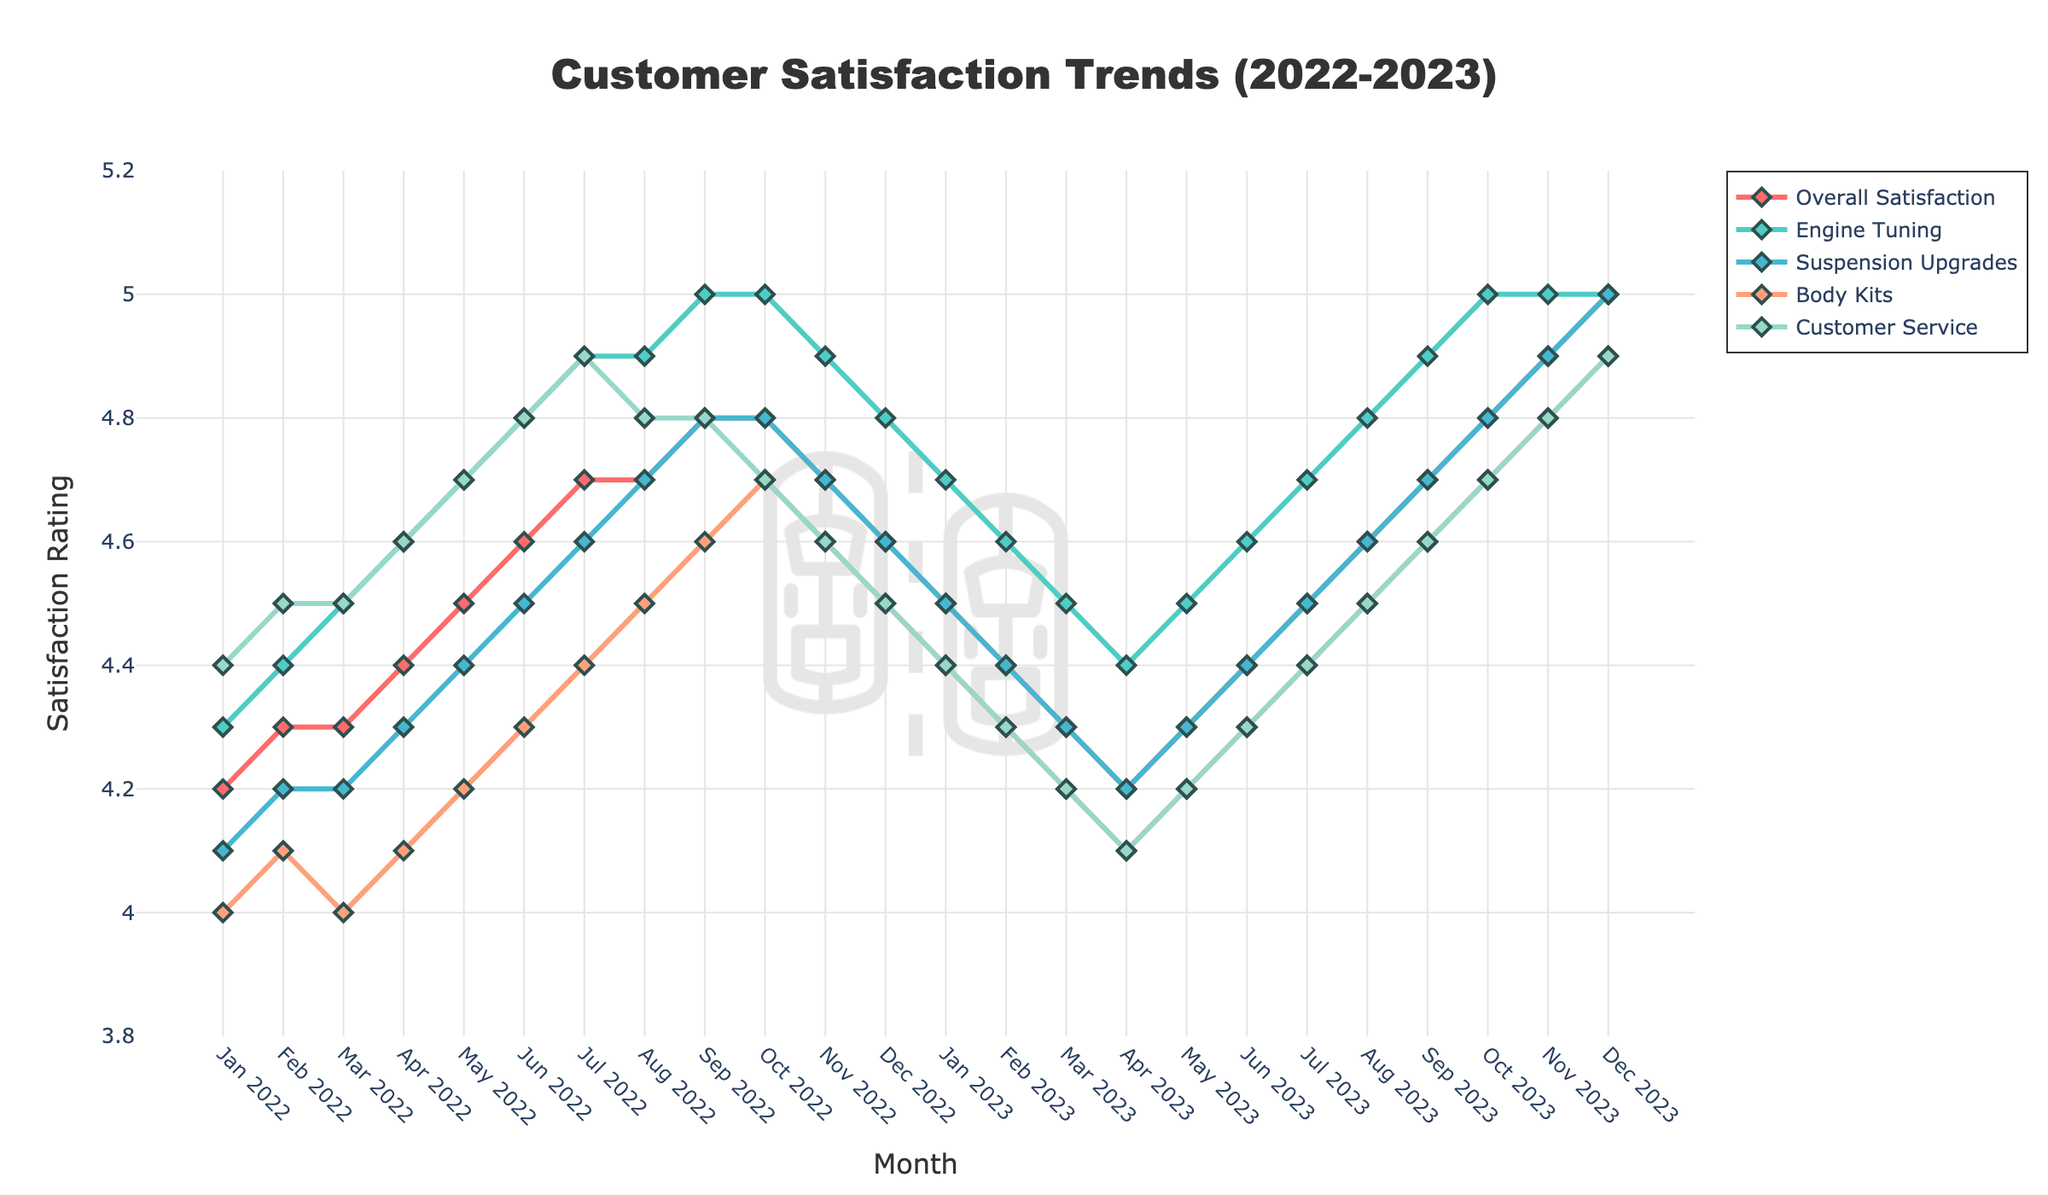Which service had the highest satisfaction rating in January 2022? In the figure, locate January 2022 on the x-axis and compare the satisfaction ratings of the services. The highest point indicates the highest satisfaction. Customer Service was the highest at 4.4.
Answer: Customer Service How did the overall satisfaction trend between January 2022 and December 2022? Look at the line for "Overall Satisfaction." It starts at 4.2 in January 2022 and rises consistently, peaking at 4.8 in September 2022, then slightly falls to 4.6 by December 2022.
Answer: It increased initially and then slightly declined Which service showed the most consistent satisfaction ratings over the 24 months? Compare the variability in the lines for each service. Engine Tuning maintains ratings between 4.4 and 5.0 without major fluctuations, indicating consistency.
Answer: Engine Tuning How much did the satisfaction rating for Body Kits change from its lowest to highest point? Identify the lowest and highest points on the Body Kits line. The lowest point is 4.0 (Jan 2022, Mar 2022), and the highest is 4.9 (Dec 2023). The change is 4.9 - 4.0.
Answer: 0.9 Which month had the highest overall satisfaction rating, and what was the rating? Check the peak points on the "Overall Satisfaction" line. It reaches its highest point in December 2023 with a rating of 5.0.
Answer: December 2023, 5.0 Between which months did Suspension Upgrades see the largest drop in satisfaction? Observe the drops in the "Suspension Upgrades" line. The most notable drop is between December 2022 (4.6) and March 2023 (4.3), a decline of 0.3 points.
Answer: December 2022 and March 2023 What is the average satisfaction rating for Customer Service over the entire period? Sum the Customer Service ratings and divide by the number of months (24). Sum is (4.4 + 4.5 + ... + 4.9). Average is the sum divided by 24.
Answer: 4.55 Which service had the highest variation in satisfaction ratings? Compare the highest and lowest points across each service line. Body Kits fluctuated between 4.0 and 4.9, indicating a variation of 0.9, the highest among the services.
Answer: Body Kits Compare the satisfaction ratings of Engine Tuning and Suspension Upgrades in November 2023. Which is higher? Locate November 2023 and compare the points for Engine Tuning and Suspension Upgrades. Engine Tuning is 5.0, and Suspension Upgrades is 4.9.
Answer: Engine Tuning is higher 